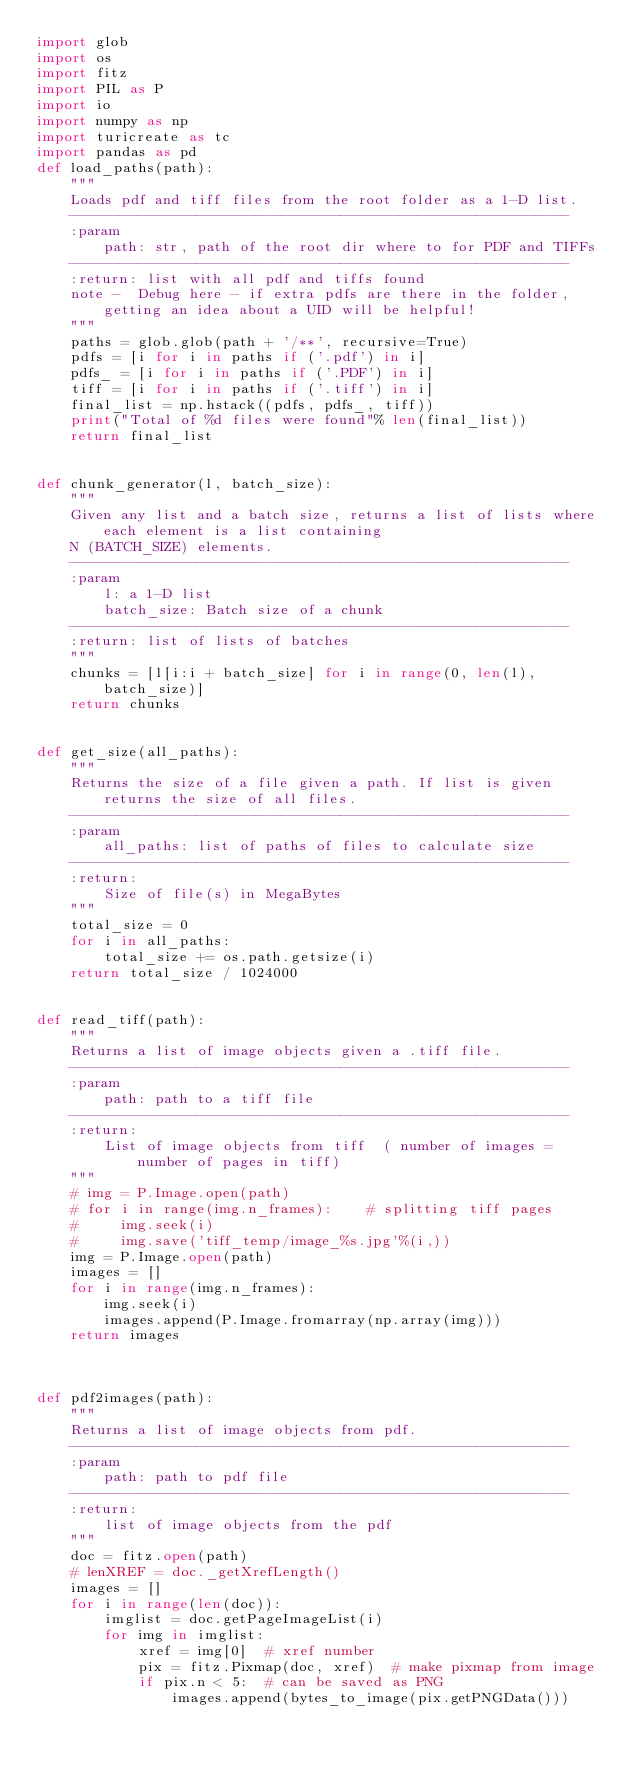<code> <loc_0><loc_0><loc_500><loc_500><_Python_>import glob
import os
import fitz
import PIL as P
import io
import numpy as np
import turicreate as tc
import pandas as pd
def load_paths(path):
    """
    Loads pdf and tiff files from the root folder as a 1-D list.
    -----------------------------------------------------------
    :param
        path: str, path of the root dir where to for PDF and TIFFs
    -----------------------------------------------------------
    :return: list with all pdf and tiffs found
    note -  Debug here - if extra pdfs are there in the folder, getting an idea about a UID will be helpful!
    """
    paths = glob.glob(path + '/**', recursive=True)
    pdfs = [i for i in paths if ('.pdf') in i]
    pdfs_ = [i for i in paths if ('.PDF') in i]
    tiff = [i for i in paths if ('.tiff') in i]
    final_list = np.hstack((pdfs, pdfs_, tiff))
    print("Total of %d files were found"% len(final_list))
    return final_list


def chunk_generator(l, batch_size):
    """
    Given any list and a batch size, returns a list of lists where each element is a list containing
    N (BATCH_SIZE) elements.
    -----------------------------------------------------------
    :param
        l: a 1-D list
        batch_size: Batch size of a chunk
    -----------------------------------------------------------
    :return: list of lists of batches
    """
    chunks = [l[i:i + batch_size] for i in range(0, len(l), batch_size)]
    return chunks


def get_size(all_paths):
    """
    Returns the size of a file given a path. If list is given returns the size of all files.
    -----------------------------------------------------------
    :param
        all_paths: list of paths of files to calculate size
    -----------------------------------------------------------
    :return:
        Size of file(s) in MegaBytes
    """
    total_size = 0
    for i in all_paths:
        total_size += os.path.getsize(i)
    return total_size / 1024000


def read_tiff(path):
    """
    Returns a list of image objects given a .tiff file.
    -----------------------------------------------------------
    :param
        path: path to a tiff file
    -----------------------------------------------------------
    :return:
        List of image objects from tiff  ( number of images = number of pages in tiff)
    """
    # img = P.Image.open(path)
    # for i in range(img.n_frames):    # splitting tiff pages
    #     img.seek(i)
    #     img.save('tiff_temp/image_%s.jpg'%(i,))
    img = P.Image.open(path)
    images = []
    for i in range(img.n_frames):
        img.seek(i)
        images.append(P.Image.fromarray(np.array(img)))
    return images



def pdf2images(path):
    """
    Returns a list of image objects from pdf.
    -----------------------------------------------------------
    :param
        path: path to pdf file
    -----------------------------------------------------------
    :return:
        list of image objects from the pdf
    """
    doc = fitz.open(path)
    # lenXREF = doc._getXrefLength()
    images = []
    for i in range(len(doc)):
        imglist = doc.getPageImageList(i)
        for img in imglist:
            xref = img[0]  # xref number
            pix = fitz.Pixmap(doc, xref)  # make pixmap from image
            if pix.n < 5:  # can be saved as PNG
                images.append(bytes_to_image(pix.getPNGData()))</code> 